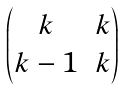Convert formula to latex. <formula><loc_0><loc_0><loc_500><loc_500>\begin{pmatrix} k & k \\ k - 1 & k \end{pmatrix}</formula> 